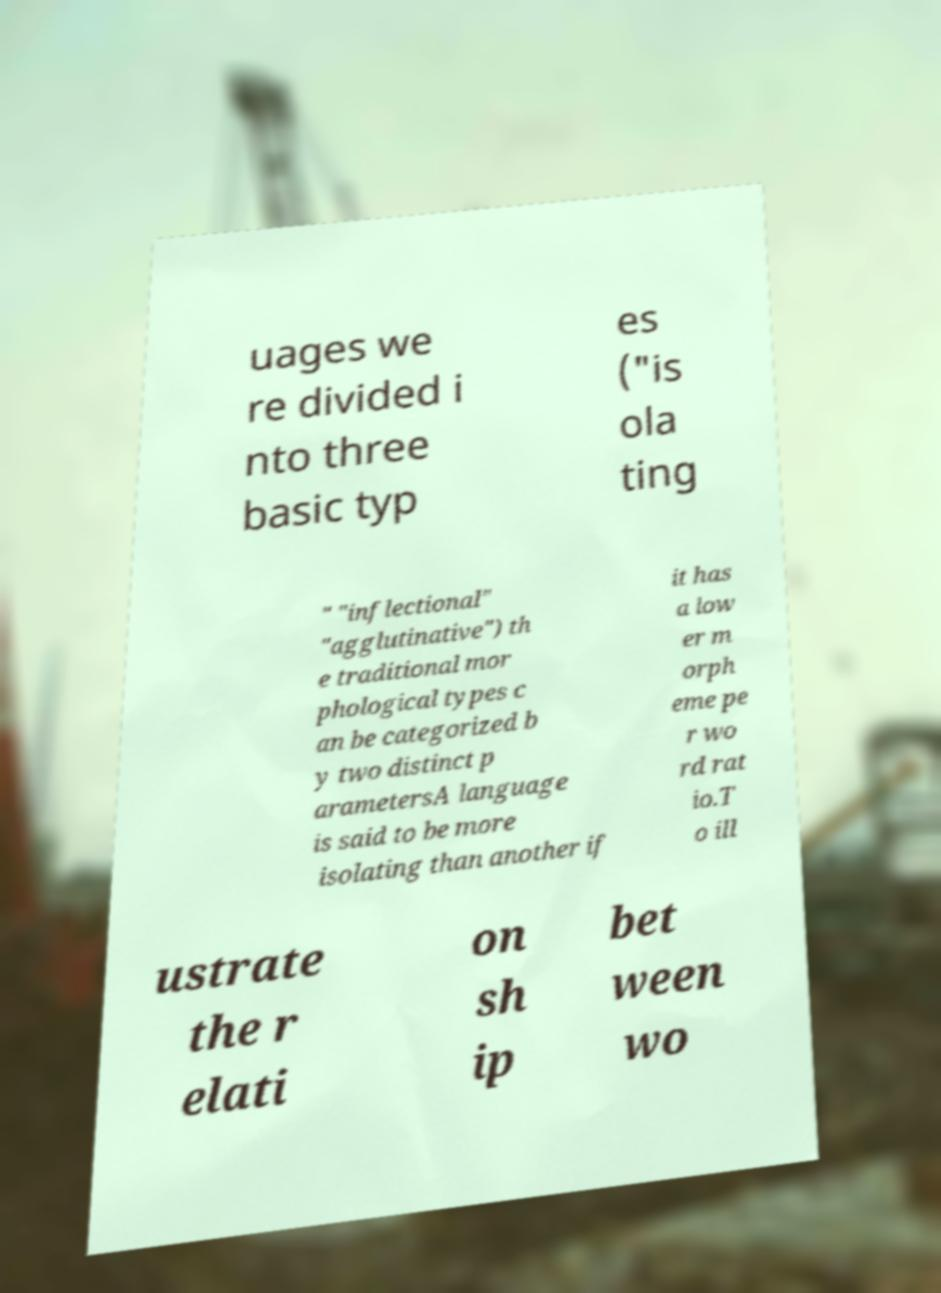Can you read and provide the text displayed in the image?This photo seems to have some interesting text. Can you extract and type it out for me? uages we re divided i nto three basic typ es ("is ola ting " "inflectional" "agglutinative") th e traditional mor phological types c an be categorized b y two distinct p arametersA language is said to be more isolating than another if it has a low er m orph eme pe r wo rd rat io.T o ill ustrate the r elati on sh ip bet ween wo 